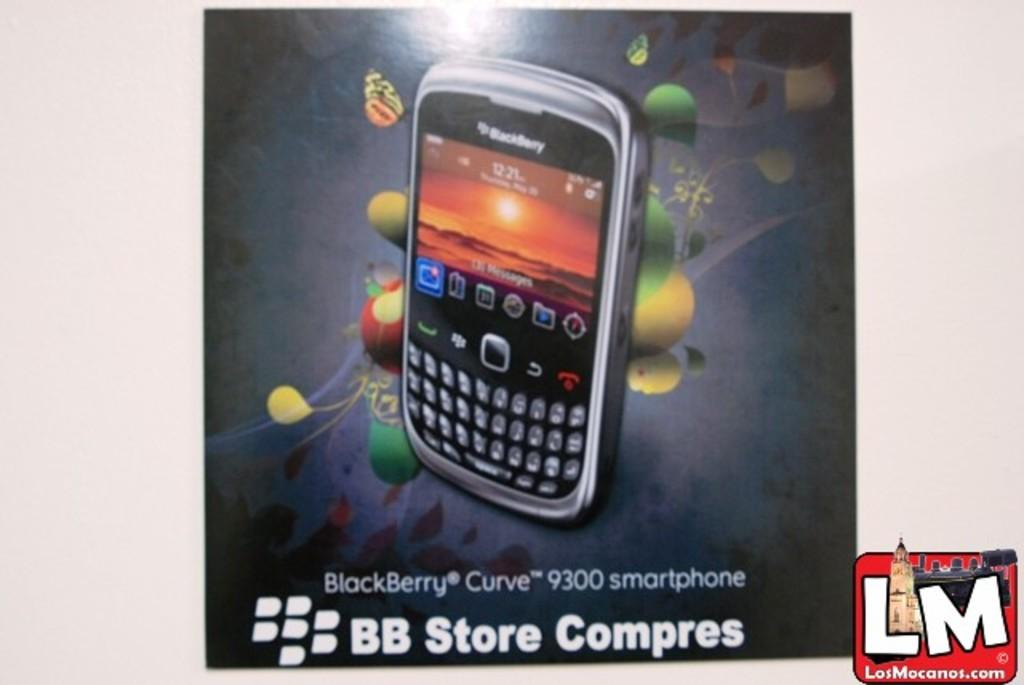<image>
Relay a brief, clear account of the picture shown. An ad for the BlackBerry Curve 9300 smartphone. 